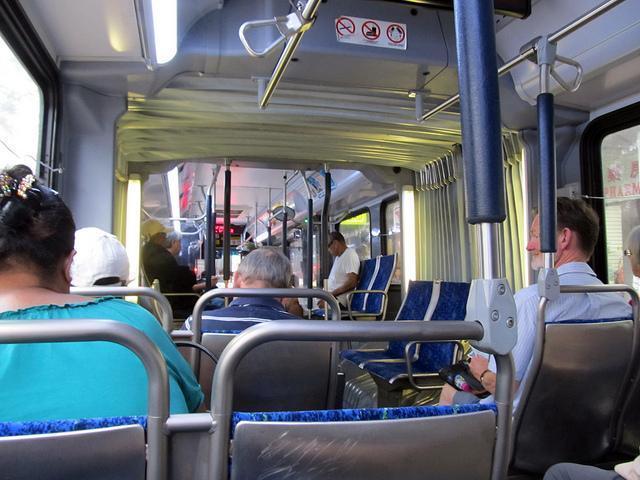What is explicitly forbidden on the bus?
Select the correct answer and articulate reasoning with the following format: 'Answer: answer
Rationale: rationale.'
Options: Spitting, eating, singing, talking. Answer: eating.
Rationale: There is a sticker above in the bus that shows various pictures of things forbidden. one has food on it with a slash. 